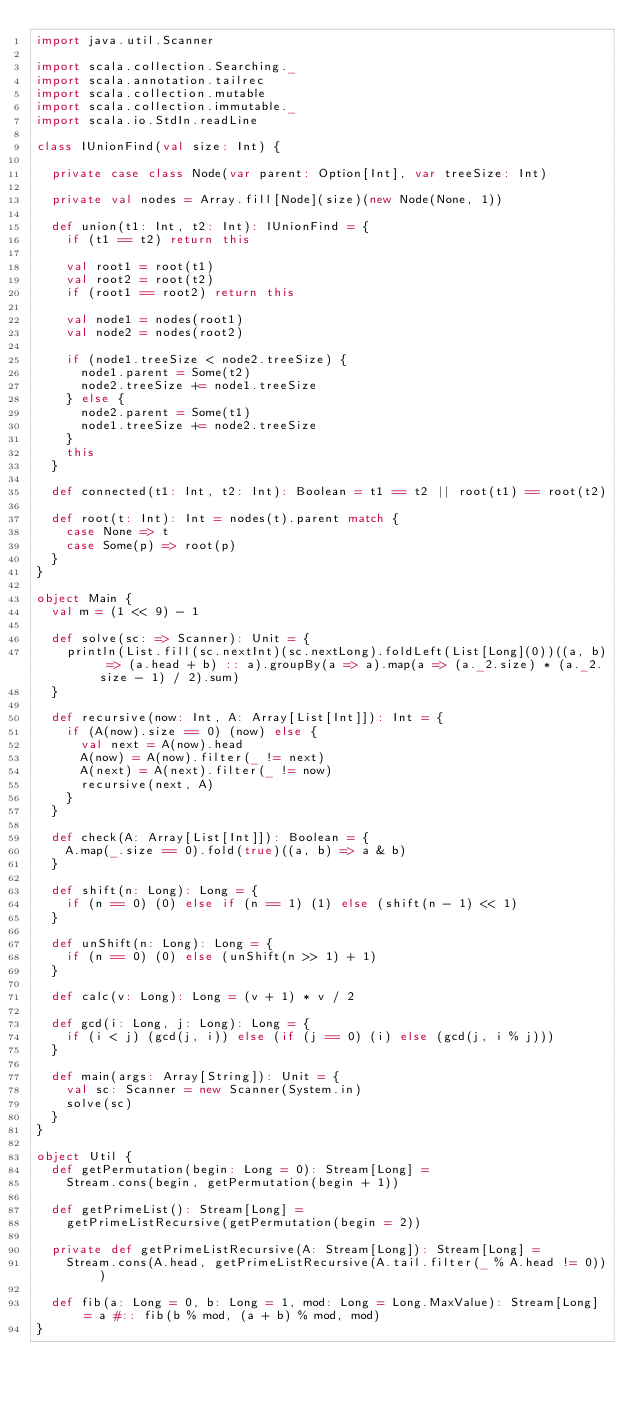<code> <loc_0><loc_0><loc_500><loc_500><_Scala_>import java.util.Scanner

import scala.collection.Searching._
import scala.annotation.tailrec
import scala.collection.mutable
import scala.collection.immutable._
import scala.io.StdIn.readLine

class IUnionFind(val size: Int) {

  private case class Node(var parent: Option[Int], var treeSize: Int)

  private val nodes = Array.fill[Node](size)(new Node(None, 1))

  def union(t1: Int, t2: Int): IUnionFind = {
    if (t1 == t2) return this

    val root1 = root(t1)
    val root2 = root(t2)
    if (root1 == root2) return this

    val node1 = nodes(root1)
    val node2 = nodes(root2)

    if (node1.treeSize < node2.treeSize) {
      node1.parent = Some(t2)
      node2.treeSize += node1.treeSize
    } else {
      node2.parent = Some(t1)
      node1.treeSize += node2.treeSize
    }
    this
  }

  def connected(t1: Int, t2: Int): Boolean = t1 == t2 || root(t1) == root(t2)

  def root(t: Int): Int = nodes(t).parent match {
    case None => t
    case Some(p) => root(p)
  }
}

object Main {
  val m = (1 << 9) - 1

  def solve(sc: => Scanner): Unit = {
    println(List.fill(sc.nextInt)(sc.nextLong).foldLeft(List[Long](0))((a, b) => (a.head + b) :: a).groupBy(a => a).map(a => (a._2.size) * (a._2.size - 1) / 2).sum)
  }

  def recursive(now: Int, A: Array[List[Int]]): Int = {
    if (A(now).size == 0) (now) else {
      val next = A(now).head
      A(now) = A(now).filter(_ != next)
      A(next) = A(next).filter(_ != now)
      recursive(next, A)
    }
  }

  def check(A: Array[List[Int]]): Boolean = {
    A.map(_.size == 0).fold(true)((a, b) => a & b)
  }

  def shift(n: Long): Long = {
    if (n == 0) (0) else if (n == 1) (1) else (shift(n - 1) << 1)
  }

  def unShift(n: Long): Long = {
    if (n == 0) (0) else (unShift(n >> 1) + 1)
  }

  def calc(v: Long): Long = (v + 1) * v / 2

  def gcd(i: Long, j: Long): Long = {
    if (i < j) (gcd(j, i)) else (if (j == 0) (i) else (gcd(j, i % j)))
  }

  def main(args: Array[String]): Unit = {
    val sc: Scanner = new Scanner(System.in)
    solve(sc)
  }
}

object Util {
  def getPermutation(begin: Long = 0): Stream[Long] =
    Stream.cons(begin, getPermutation(begin + 1))

  def getPrimeList(): Stream[Long] =
    getPrimeListRecursive(getPermutation(begin = 2))

  private def getPrimeListRecursive(A: Stream[Long]): Stream[Long] =
    Stream.cons(A.head, getPrimeListRecursive(A.tail.filter(_ % A.head != 0)))

  def fib(a: Long = 0, b: Long = 1, mod: Long = Long.MaxValue): Stream[Long] = a #:: fib(b % mod, (a + b) % mod, mod)
}
</code> 